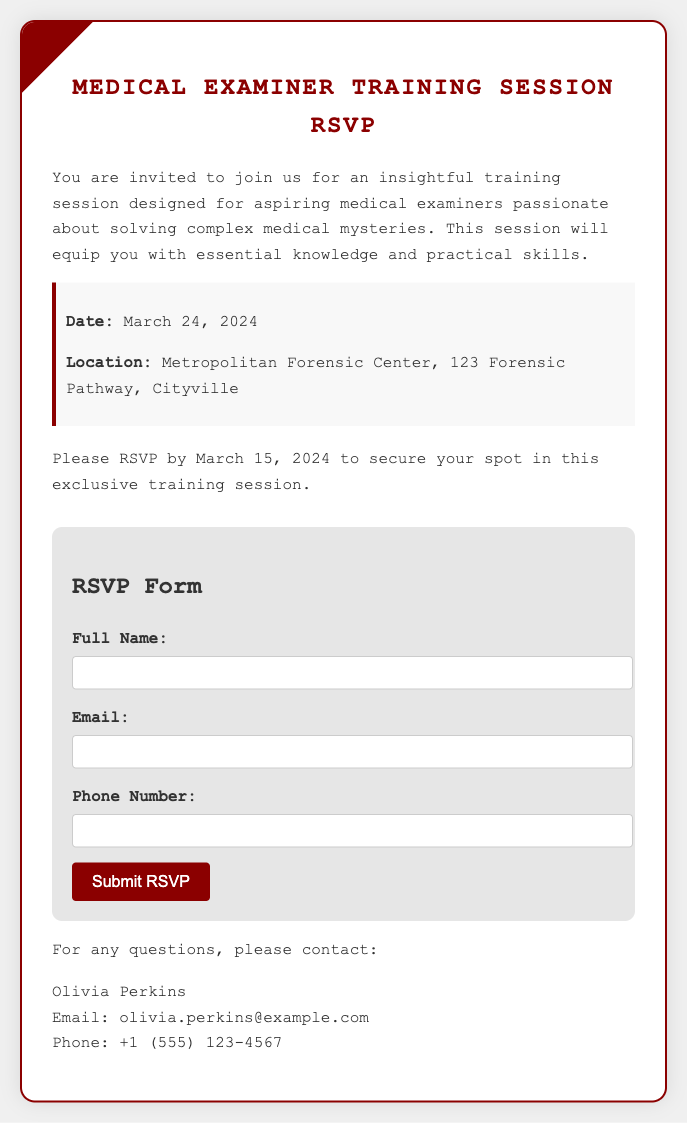What is the date of the training session? The date of the training session is explicitly stated in the document as March 24, 2024.
Answer: March 24, 2024 Where is the training session located? The location is provided in the details section of the document, specifically as Metropolitan Forensic Center, 123 Forensic Pathway, Cityville.
Answer: Metropolitan Forensic Center, 123 Forensic Pathway, Cityville Who should attendees contact for questions? The document lists Olivia Perkins as the contact person for any questions regarding the session.
Answer: Olivia Perkins What is the RSVP deadline? The RSVP deadline is specified in the document, which states to RSVP by March 15, 2024.
Answer: March 15, 2024 What is required to submit the RSVP form? The form specifies three pieces of information required: Full Name, Email, and Phone Number.
Answer: Full Name, Email, and Phone Number What is the purpose of this training session? The document states that the training session is designed for aspiring medical examiners passionate about solving complex medical mysteries.
Answer: solving complex medical mysteries What type of form is included in the document? The document includes a form that allows individuals to RSVP for the training session, as highlighted in the RSVP Form section.
Answer: RSVP Form What colors are used in the design of the document? The document prominently features a body background color of light gray and a card border color of dark red.
Answer: light gray and dark red 